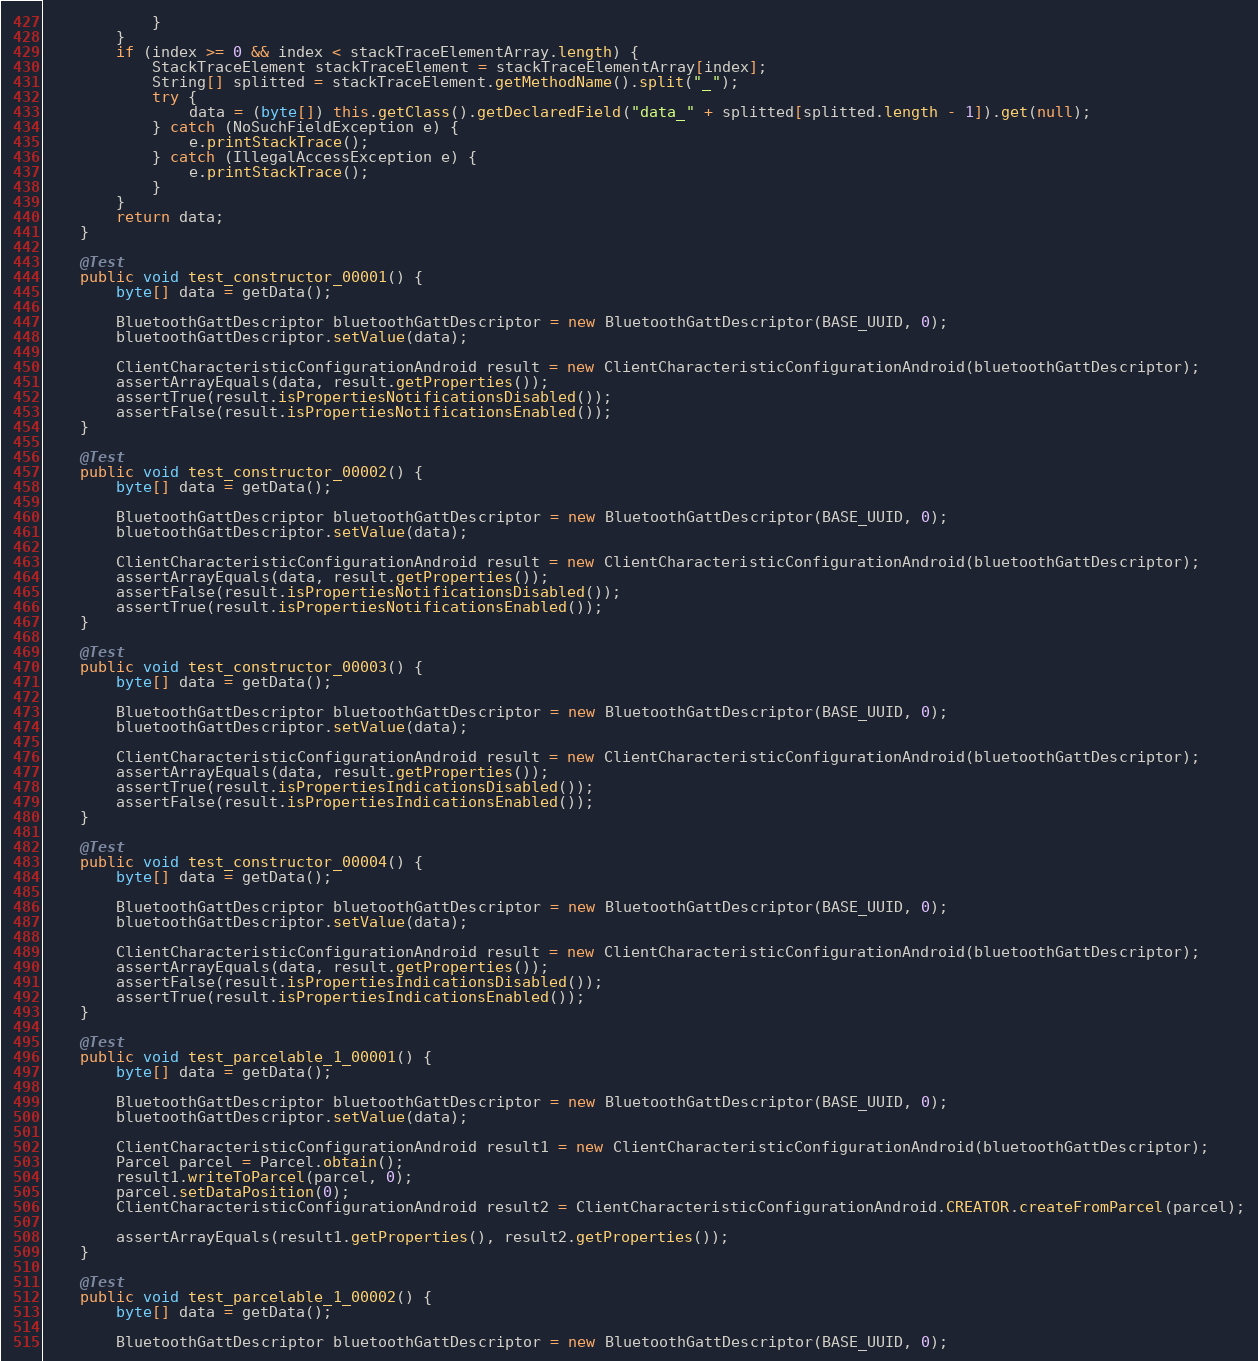<code> <loc_0><loc_0><loc_500><loc_500><_Java_>            }
        }
        if (index >= 0 && index < stackTraceElementArray.length) {
            StackTraceElement stackTraceElement = stackTraceElementArray[index];
            String[] splitted = stackTraceElement.getMethodName().split("_");
            try {
                data = (byte[]) this.getClass().getDeclaredField("data_" + splitted[splitted.length - 1]).get(null);
            } catch (NoSuchFieldException e) {
                e.printStackTrace();
            } catch (IllegalAccessException e) {
                e.printStackTrace();
            }
        }
        return data;
    }

    @Test
    public void test_constructor_00001() {
        byte[] data = getData();

        BluetoothGattDescriptor bluetoothGattDescriptor = new BluetoothGattDescriptor(BASE_UUID, 0);
        bluetoothGattDescriptor.setValue(data);

        ClientCharacteristicConfigurationAndroid result = new ClientCharacteristicConfigurationAndroid(bluetoothGattDescriptor);
        assertArrayEquals(data, result.getProperties());
        assertTrue(result.isPropertiesNotificationsDisabled());
        assertFalse(result.isPropertiesNotificationsEnabled());
    }

    @Test
    public void test_constructor_00002() {
        byte[] data = getData();

        BluetoothGattDescriptor bluetoothGattDescriptor = new BluetoothGattDescriptor(BASE_UUID, 0);
        bluetoothGattDescriptor.setValue(data);

        ClientCharacteristicConfigurationAndroid result = new ClientCharacteristicConfigurationAndroid(bluetoothGattDescriptor);
        assertArrayEquals(data, result.getProperties());
        assertFalse(result.isPropertiesNotificationsDisabled());
        assertTrue(result.isPropertiesNotificationsEnabled());
    }

    @Test
    public void test_constructor_00003() {
        byte[] data = getData();

        BluetoothGattDescriptor bluetoothGattDescriptor = new BluetoothGattDescriptor(BASE_UUID, 0);
        bluetoothGattDescriptor.setValue(data);

        ClientCharacteristicConfigurationAndroid result = new ClientCharacteristicConfigurationAndroid(bluetoothGattDescriptor);
        assertArrayEquals(data, result.getProperties());
        assertTrue(result.isPropertiesIndicationsDisabled());
        assertFalse(result.isPropertiesIndicationsEnabled());
    }

    @Test
    public void test_constructor_00004() {
        byte[] data = getData();

        BluetoothGattDescriptor bluetoothGattDescriptor = new BluetoothGattDescriptor(BASE_UUID, 0);
        bluetoothGattDescriptor.setValue(data);

        ClientCharacteristicConfigurationAndroid result = new ClientCharacteristicConfigurationAndroid(bluetoothGattDescriptor);
        assertArrayEquals(data, result.getProperties());
        assertFalse(result.isPropertiesIndicationsDisabled());
        assertTrue(result.isPropertiesIndicationsEnabled());
    }

    @Test
    public void test_parcelable_1_00001() {
        byte[] data = getData();

        BluetoothGattDescriptor bluetoothGattDescriptor = new BluetoothGattDescriptor(BASE_UUID, 0);
        bluetoothGattDescriptor.setValue(data);

        ClientCharacteristicConfigurationAndroid result1 = new ClientCharacteristicConfigurationAndroid(bluetoothGattDescriptor);
        Parcel parcel = Parcel.obtain();
        result1.writeToParcel(parcel, 0);
        parcel.setDataPosition(0);
        ClientCharacteristicConfigurationAndroid result2 = ClientCharacteristicConfigurationAndroid.CREATOR.createFromParcel(parcel);

        assertArrayEquals(result1.getProperties(), result2.getProperties());
    }

    @Test
    public void test_parcelable_1_00002() {
        byte[] data = getData();

        BluetoothGattDescriptor bluetoothGattDescriptor = new BluetoothGattDescriptor(BASE_UUID, 0);</code> 